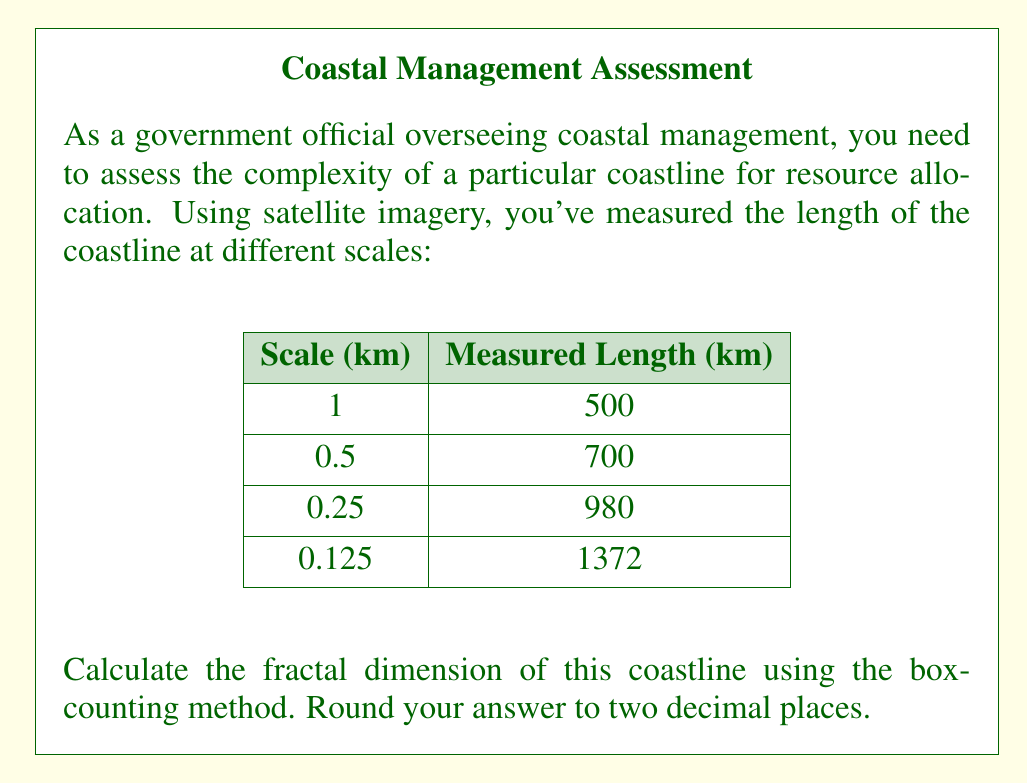Help me with this question. To calculate the fractal dimension using the box-counting method, we'll follow these steps:

1) The box-counting method is based on the relationship:
   $$N(s) \propto s^{-D}$$
   where $N(s)$ is the number of boxes of size $s$ needed to cover the object, and $D$ is the fractal dimension.

2) Taking logarithms of both sides:
   $$\log N(s) = -D \log s + C$$

3) This is a linear equation where $-D$ is the slope. We can find $D$ by plotting $\log N(s)$ against $\log s$ and calculating the slope.

4) In our case, $N(s)$ is the measured length divided by the scale:

   Scale (s) | N(s)   | log(s)  | log(N(s))
   1         | 500    | 0       | 6.2146
   0.5       | 1400   | -0.3010 | 7.2442
   0.25      | 3920   | -0.6021 | 8.2738
   0.125     | 10976  | -0.9031 | 9.3035

5) To find the slope, we can use the formula:
   $$D = -\frac{\sum (x_i - \bar{x})(y_i - \bar{y})}{\sum (x_i - \bar{x})^2}$$
   where $x_i = \log(s_i)$ and $y_i = \log(N(s_i))$

6) Calculating:
   $\bar{x} = -0.4516$
   $\bar{y} = 7.7590$

   $$D = -\frac{(-0.4516 \times -1.5444) + ... + (-0.4516 \times 1.5445)}{(-0.4516)^2 + ... + (-0.4516)^2}$$

7) This gives us $D = 1.1889$

8) Rounding to two decimal places: $D = 1.19$
Answer: 1.19 